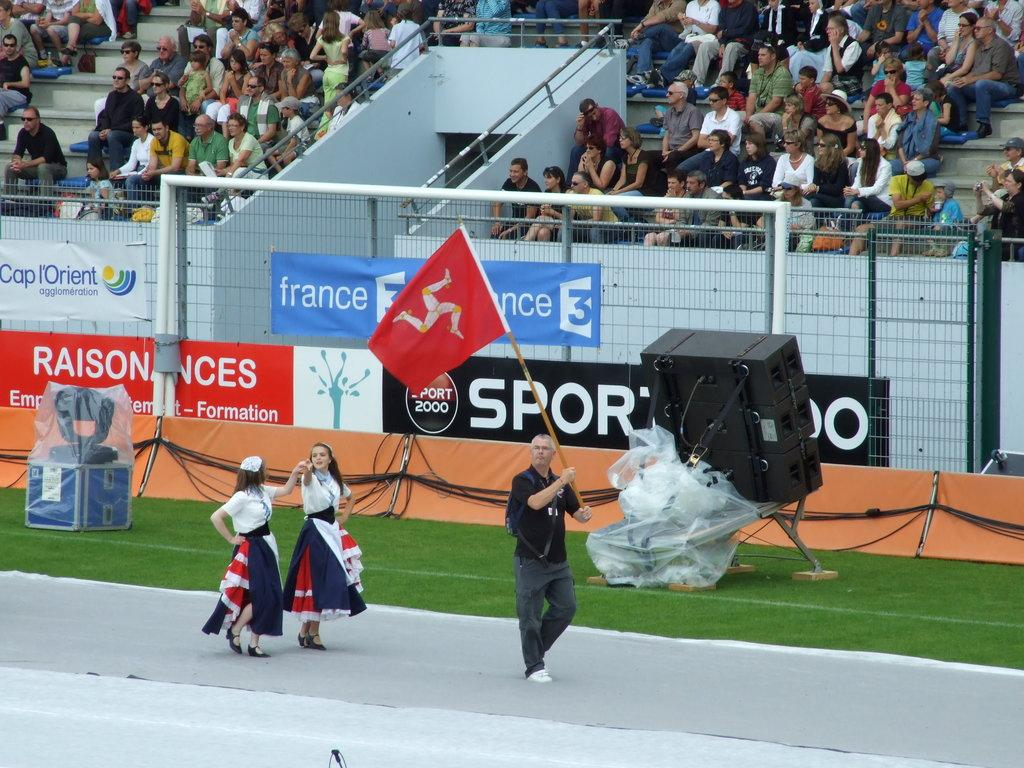<image>
Share a concise interpretation of the image provided. Two woman walk on a track in front of an ad for FRANCE 